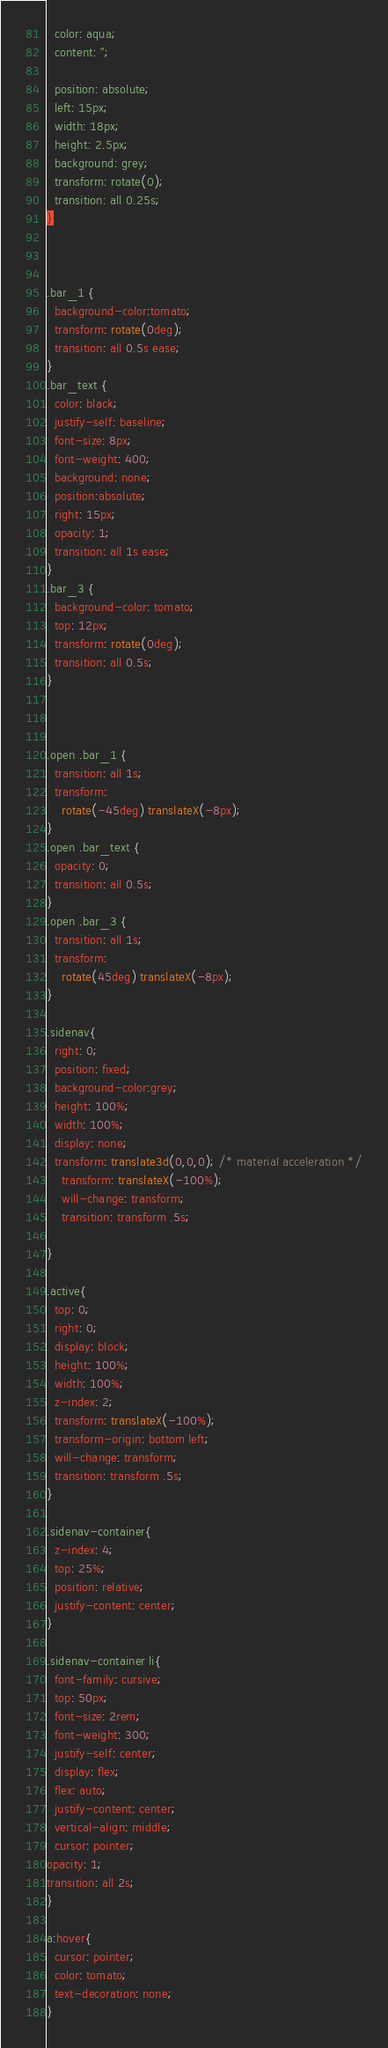<code> <loc_0><loc_0><loc_500><loc_500><_CSS_>  color: aqua;
  content: '';

  position: absolute;
  left: 15px;
  width: 18px;
  height: 2.5px;
  background: grey;
  transform: rotate(0);
  transition: all 0.25s;
}



.bar_1 {
  background-color:tomato;
  transform: rotate(0deg);
  transition: all 0.5s ease;
}
.bar_text {
  color: black;
  justify-self: baseline;
  font-size: 8px;
  font-weight: 400;
  background: none;
  position:absolute;
  right: 15px;
  opacity: 1;
  transition: all 1s ease;
}
.bar_3 {
  background-color: tomato;
  top: 12px;
  transform: rotate(0deg);
  transition: all 0.5s;
}



.open .bar_1 {
  transition: all 1s;
  transform: 
    rotate(-45deg) translateX(-8px);
}
.open .bar_text {
  opacity: 0;
  transition: all 0.5s;
}
.open .bar_3 {
  transition: all 1s;
  transform: 
    rotate(45deg) translateX(-8px);
} 

.sidenav{
  right: 0;
  position: fixed;
  background-color:grey;
  height: 100%;
  width: 100%;
  display: none;
  transform: translate3d(0,0,0); /* material acceleration */
	transform: translateX(-100%);
	will-change: transform;
	transition: transform .5s;
 
}

.active{
  top: 0;
  right: 0;
  display: block;
  height: 100%;
  width: 100%;
  z-index: 2;
  transform: translateX(-100%);
  transform-origin: bottom left;
  will-change: transform;
  transition: transform .5s;
}

.sidenav-container{
  z-index: 4;
  top: 25%;
  position: relative;
  justify-content: center;
}

.sidenav-container li{
  font-family: cursive;
  top: 50px;
  font-size: 2rem;
  font-weight: 300;
  justify-self: center;
  display: flex;
  flex: auto;
  justify-content: center;
  vertical-align: middle;
  cursor: pointer;
opacity: 1;
transition: all 2s;
}

a:hover{
  cursor: pointer;
  color: tomato;
  text-decoration: none;
}
</code> 